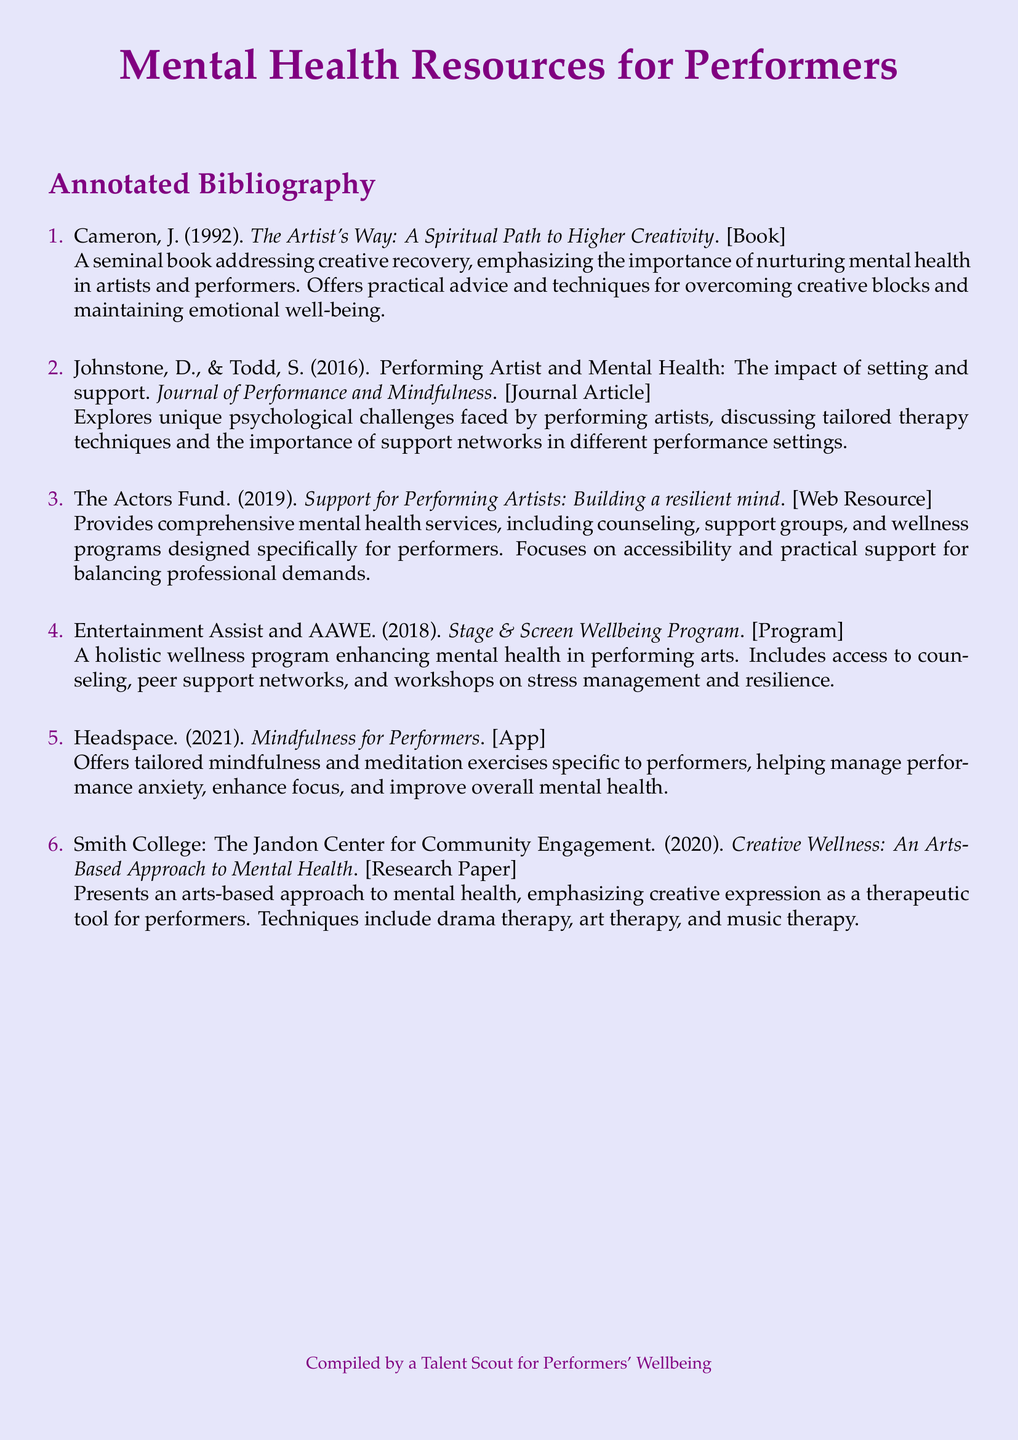What is the title of the first resource listed? The first resource is titled "The Artist's Way: A Spiritual Path to Higher Creativity".
Answer: The Artist's Way: A Spiritual Path to Higher Creativity Who are the authors of the second resource? The second resource is authored by D. Johnstone and S. Todd.
Answer: D. Johnstone and S. Todd What year was the web resource published? The web resource was published in the year 2019.
Answer: 2019 What is a key feature of the "Stage & Screen Wellbeing Program"? A key feature includes access to counseling and peer support networks.
Answer: Counseling and peer support networks Which therapy techniques are emphasized in the research paper from Smith College? The research paper emphasizes drama therapy, art therapy, and music therapy.
Answer: Drama therapy, art therapy, and music therapy How many resources are listed in the annotated bibliography? There are six resources listed in the annotated bibliography.
Answer: Six What does the Actors Fund focus on in its services? The Actors Fund focuses on accessibility and practical support for balancing professional demands.
Answer: Accessibility and practical support What is the main emphasis of the book "The Artist's Way"? The book emphasizes nurturing mental health in artists and performers.
Answer: Nurturing mental health in artists and performers 